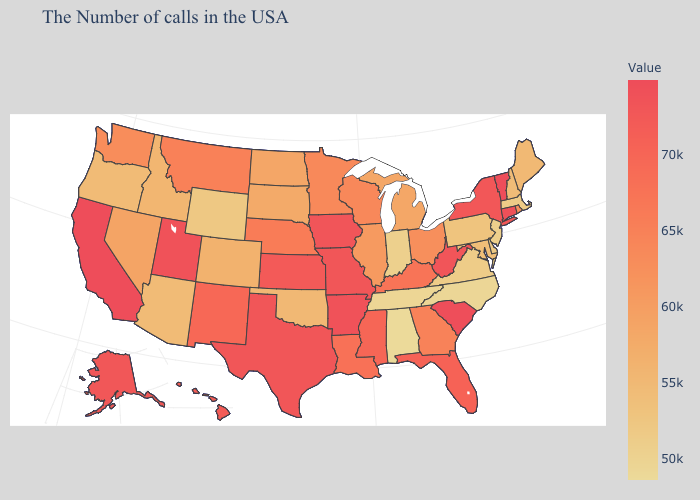Which states have the lowest value in the South?
Short answer required. Alabama. Does Maine have the highest value in the USA?
Concise answer only. No. Which states have the lowest value in the South?
Write a very short answer. Alabama. Among the states that border Massachusetts , which have the highest value?
Quick response, please. Vermont. Does New Hampshire have the lowest value in the USA?
Quick response, please. No. Which states hav the highest value in the MidWest?
Answer briefly. Iowa. 